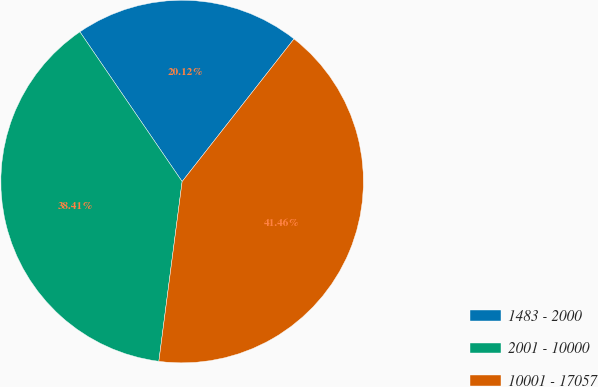Convert chart. <chart><loc_0><loc_0><loc_500><loc_500><pie_chart><fcel>1483 - 2000<fcel>2001 - 10000<fcel>10001 - 17057<nl><fcel>20.12%<fcel>38.41%<fcel>41.46%<nl></chart> 